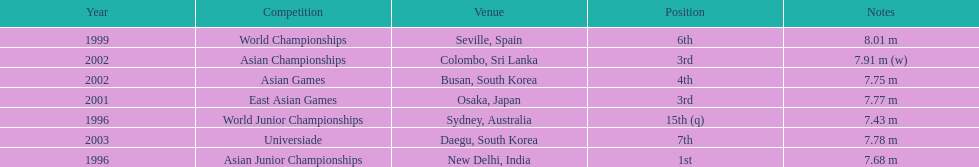How many times did his jump surpass 7.70 m? 5. 